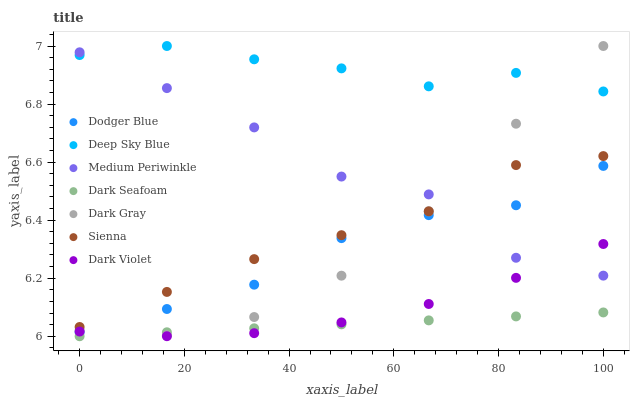Does Dark Seafoam have the minimum area under the curve?
Answer yes or no. Yes. Does Deep Sky Blue have the maximum area under the curve?
Answer yes or no. Yes. Does Medium Periwinkle have the minimum area under the curve?
Answer yes or no. No. Does Medium Periwinkle have the maximum area under the curve?
Answer yes or no. No. Is Dark Seafoam the smoothest?
Answer yes or no. Yes. Is Medium Periwinkle the roughest?
Answer yes or no. Yes. Is Dark Violet the smoothest?
Answer yes or no. No. Is Dark Violet the roughest?
Answer yes or no. No. Does Dark Seafoam have the lowest value?
Answer yes or no. Yes. Does Medium Periwinkle have the lowest value?
Answer yes or no. No. Does Deep Sky Blue have the highest value?
Answer yes or no. Yes. Does Medium Periwinkle have the highest value?
Answer yes or no. No. Is Dark Seafoam less than Dodger Blue?
Answer yes or no. Yes. Is Sienna greater than Dark Seafoam?
Answer yes or no. Yes. Does Dark Violet intersect Dodger Blue?
Answer yes or no. Yes. Is Dark Violet less than Dodger Blue?
Answer yes or no. No. Is Dark Violet greater than Dodger Blue?
Answer yes or no. No. Does Dark Seafoam intersect Dodger Blue?
Answer yes or no. No. 